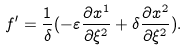<formula> <loc_0><loc_0><loc_500><loc_500>f ^ { \prime } = \frac { 1 } { \delta } ( - \varepsilon \frac { \partial x ^ { 1 } } { \partial \xi ^ { 2 } } + \delta \frac { \partial x ^ { 2 } } { \partial \xi ^ { 2 } } ) .</formula> 